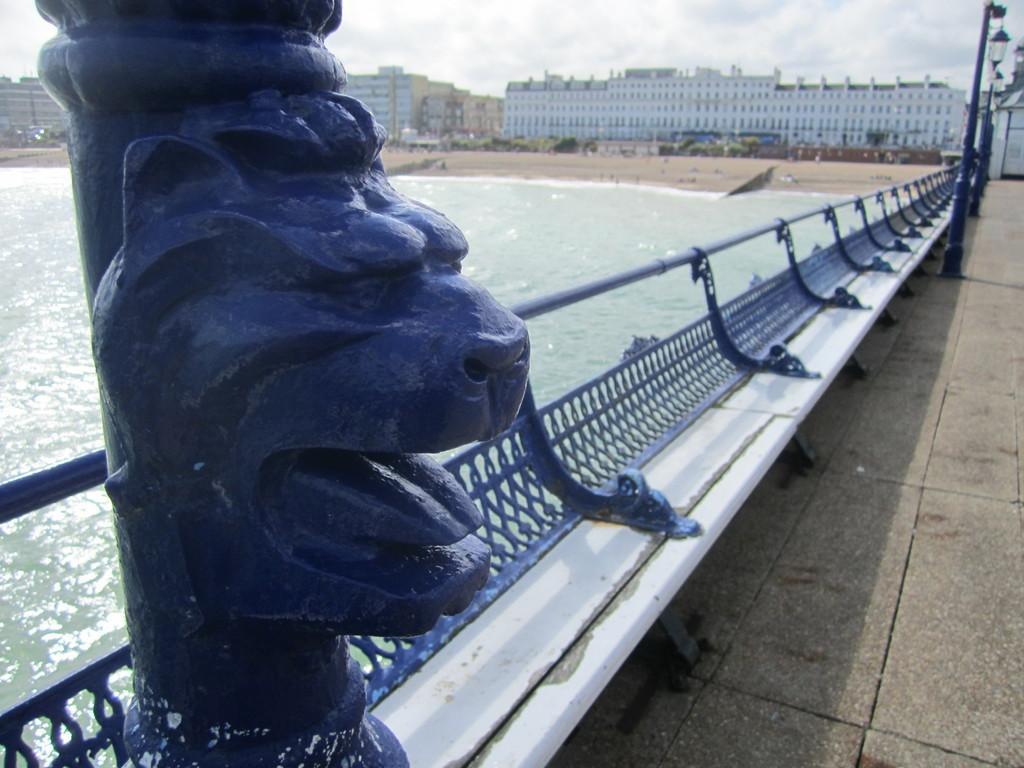How would you summarize this image in a sentence or two? In the foreground of the picture there are benches and an iron sculpture over a pole. On the right we can see street lights. In the middle of the picture we can see water body, beach. In the background there are buildings and we can see trees. at the top there is sky. On the right it is pavement. 